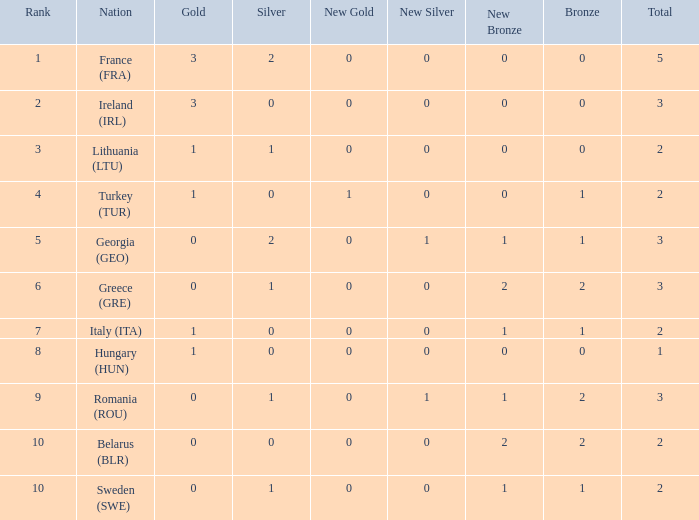What's the total of rank 8 when Silver medals are 0 and gold is more than 1? 0.0. 